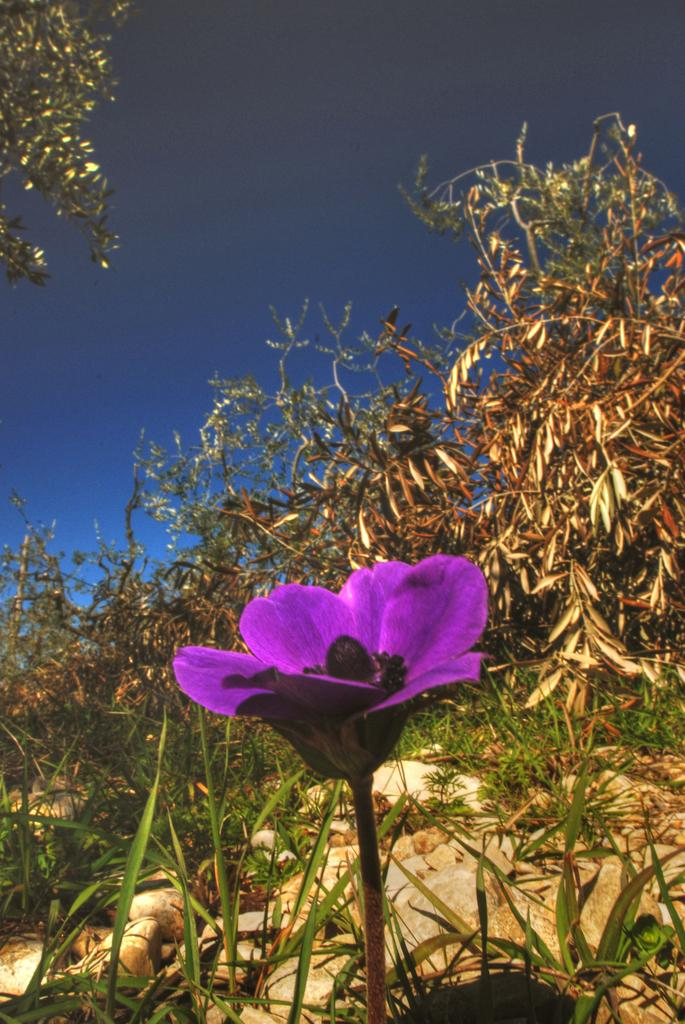Where was the picture taken? The picture was clicked outside. What can be seen in the foreground of the image? There is a flower and rocks in the foreground of the image. What type of vegetation is present in the image? There are plants in the image. What can be seen in the background of the image? The sky is visible in the background of the image, along with other objects. What color is the top of the cub in the image? There is no cub present in the image, so it is not possible to determine the color of its top. 